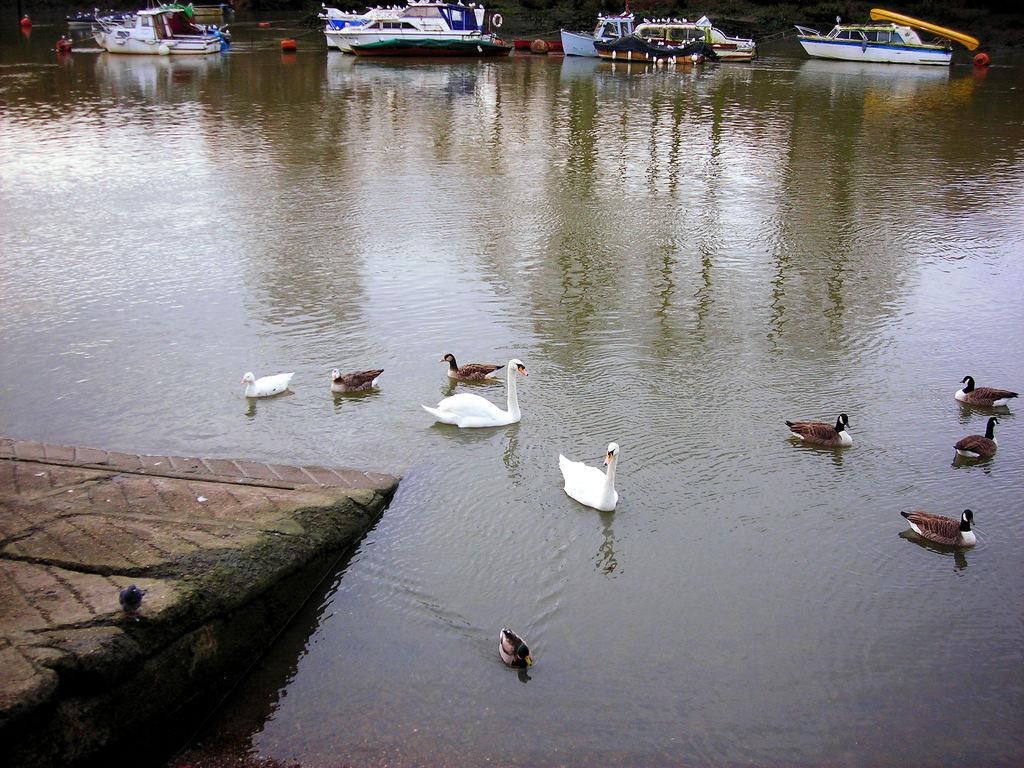What type of vehicles can be seen in the image? There are boats in the image. What safety feature is present in the image? There are safety rings in the image. What type of animals are on the surface of the water in the image? There are ducks on the surface of the water in the image. What can be seen on the left side of the image? There is a path on the left side of the image. Where is the poison located in the image? There is no poison present in the image. What type of structure is the dock in the image? There is no dock present in the image. 